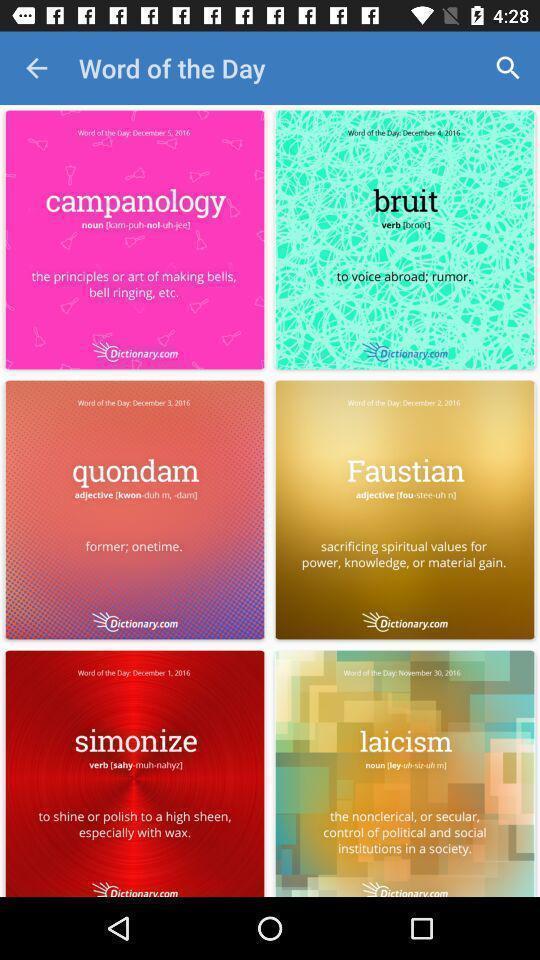Provide a textual representation of this image. Page of a vocabulary learning app. 